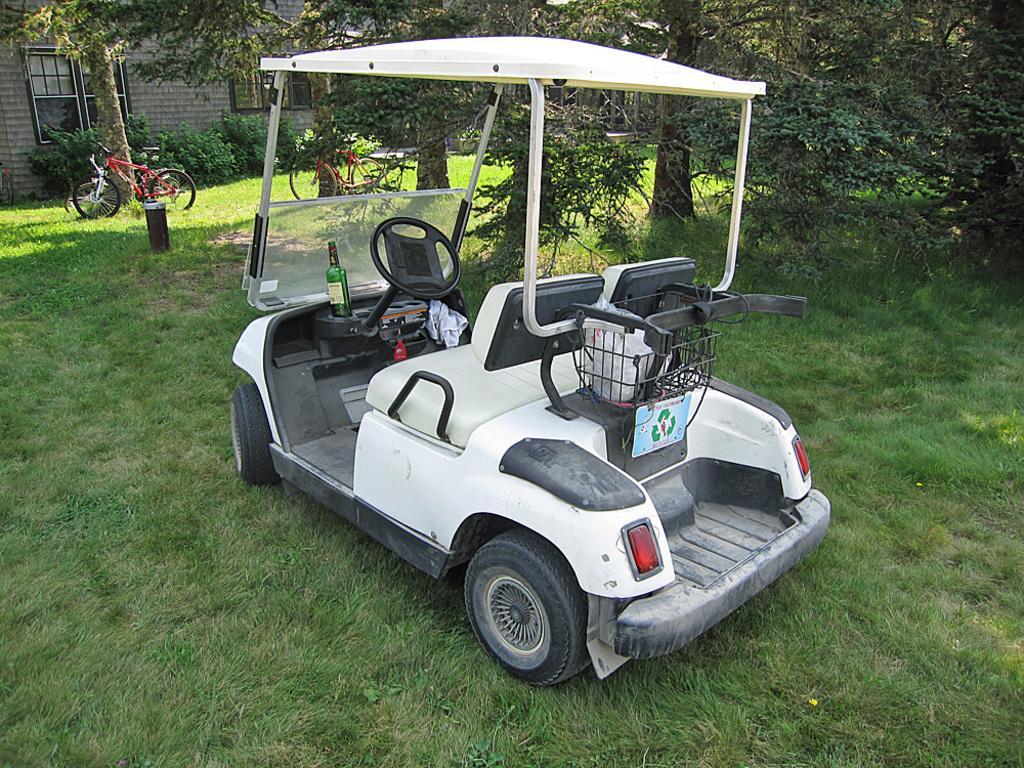In one or two sentences, can you explain what this image depicts? In this picture I can see vehicles on the grass, there are plants, trees and it is looking like a house. 